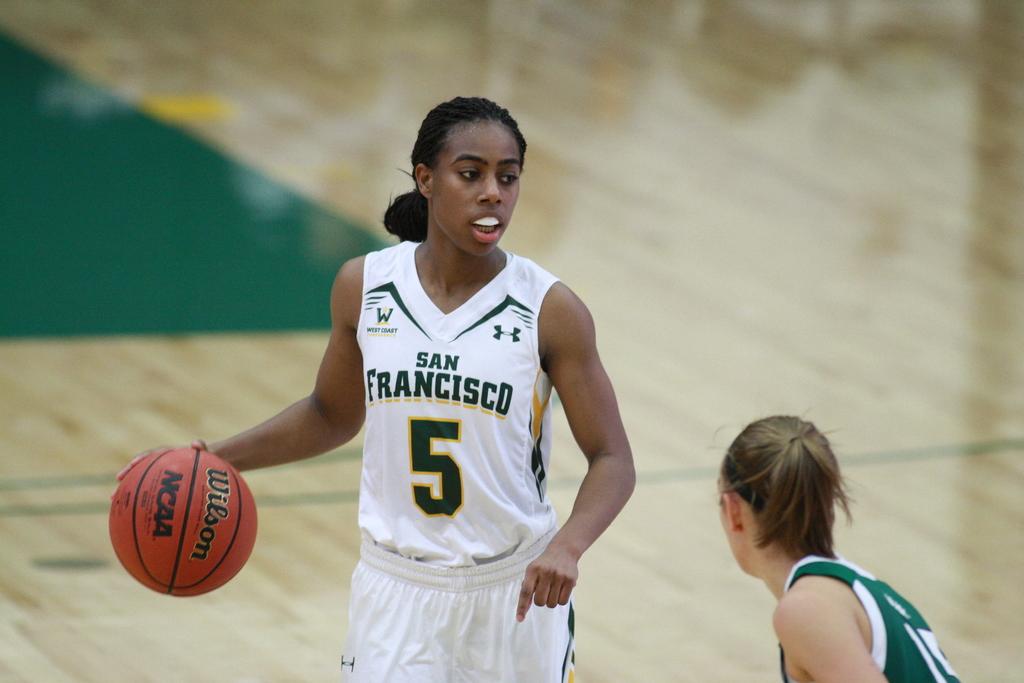What city does the team in white play for?
Provide a short and direct response. San francisco. What is the number of the jersey of the player in white?
Make the answer very short. 5. 